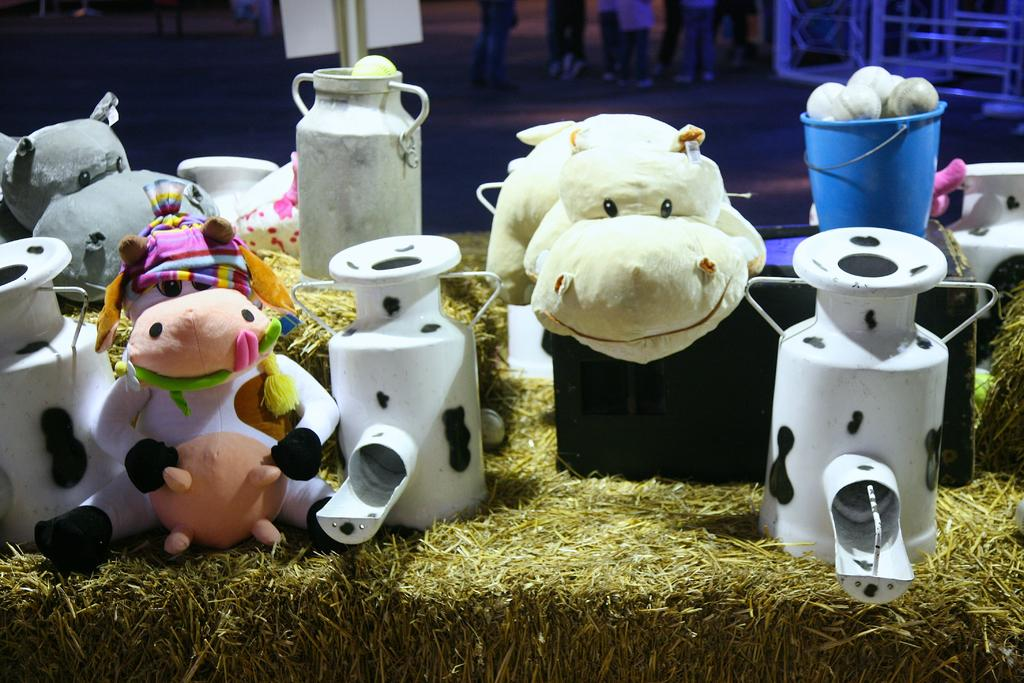What is the main subject of the picture? The main subject of the picture is a model of a farmhouse. What role does the father play in the functioning of the farmhouse in the image? There is no father or any indication of the functioning of the farmhouse in the image. How many eyes can be seen on the farmhouse in the image? The farmhouse is a model and does not have eyes. What type of friction can be observed between the farmhouse and the ground in the image? The farmhouse is a model and does not have any friction with the ground in the image. 